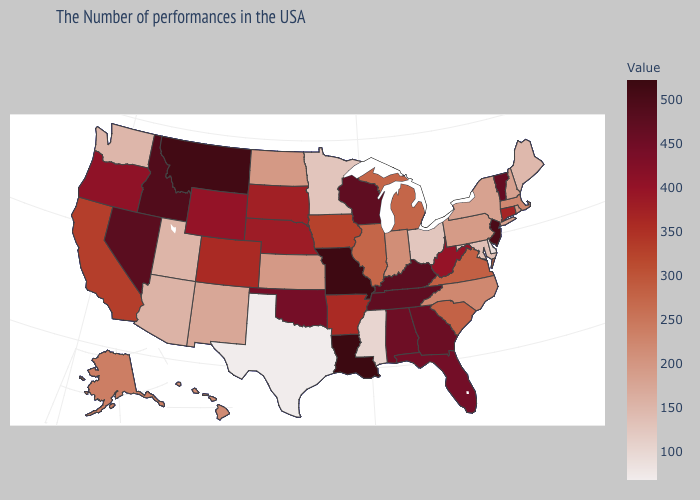Among the states that border Arizona , does Utah have the lowest value?
Keep it brief. Yes. Is the legend a continuous bar?
Quick response, please. Yes. Does Oregon have the highest value in the West?
Be succinct. No. 